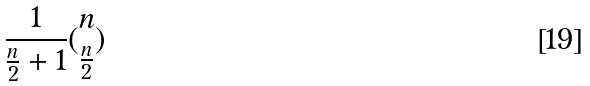Convert formula to latex. <formula><loc_0><loc_0><loc_500><loc_500>\frac { 1 } { \frac { n } { 2 } + 1 } ( \begin{matrix} n \\ \frac { n } { 2 } \end{matrix} )</formula> 